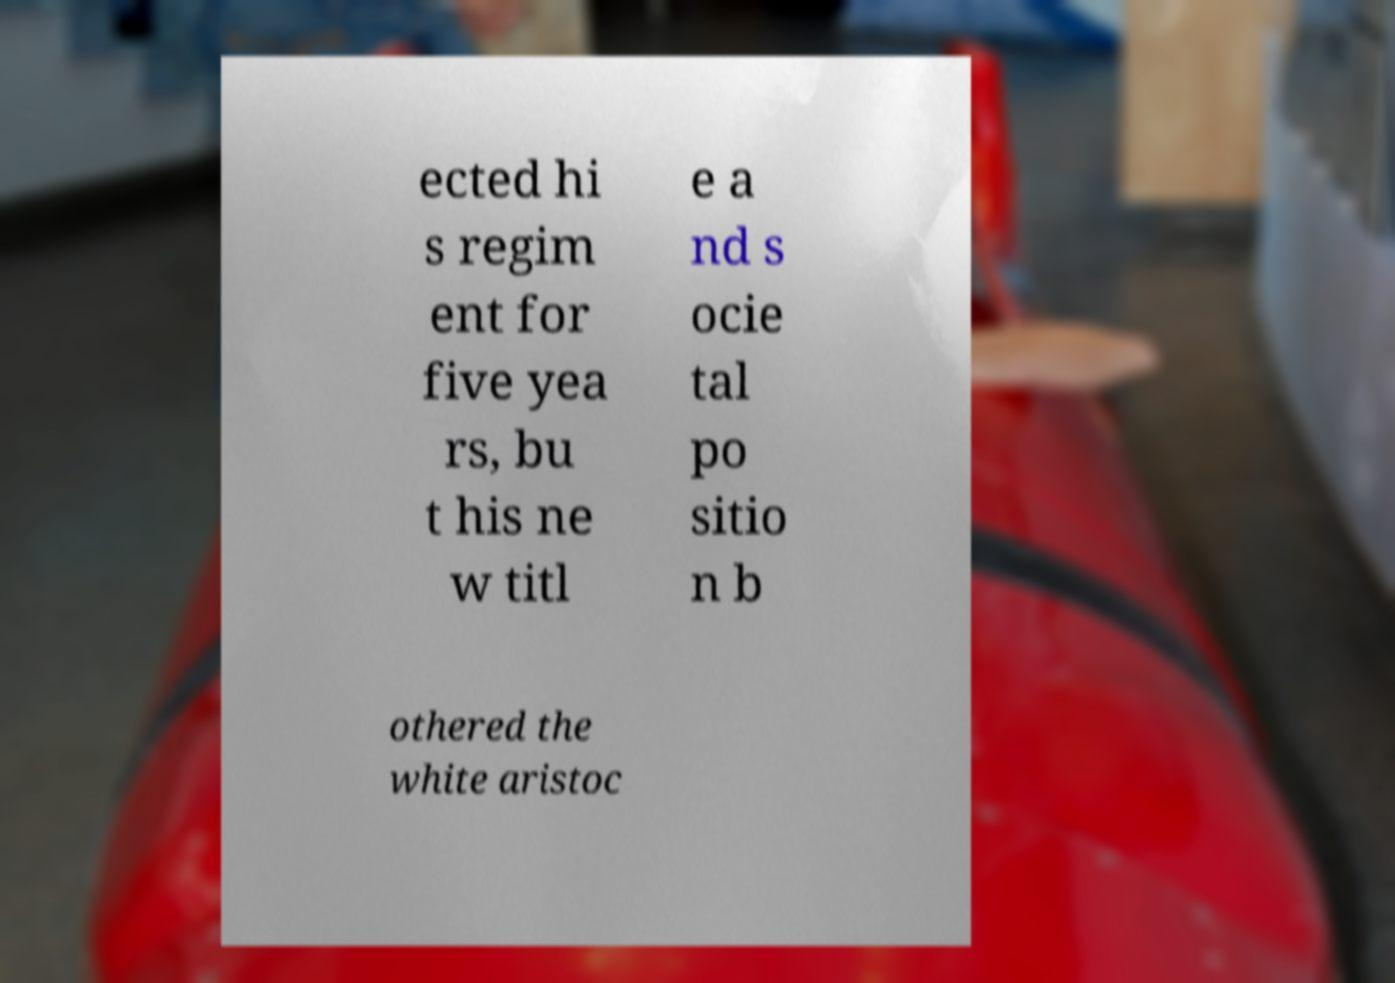Can you read and provide the text displayed in the image?This photo seems to have some interesting text. Can you extract and type it out for me? ected hi s regim ent for five yea rs, bu t his ne w titl e a nd s ocie tal po sitio n b othered the white aristoc 